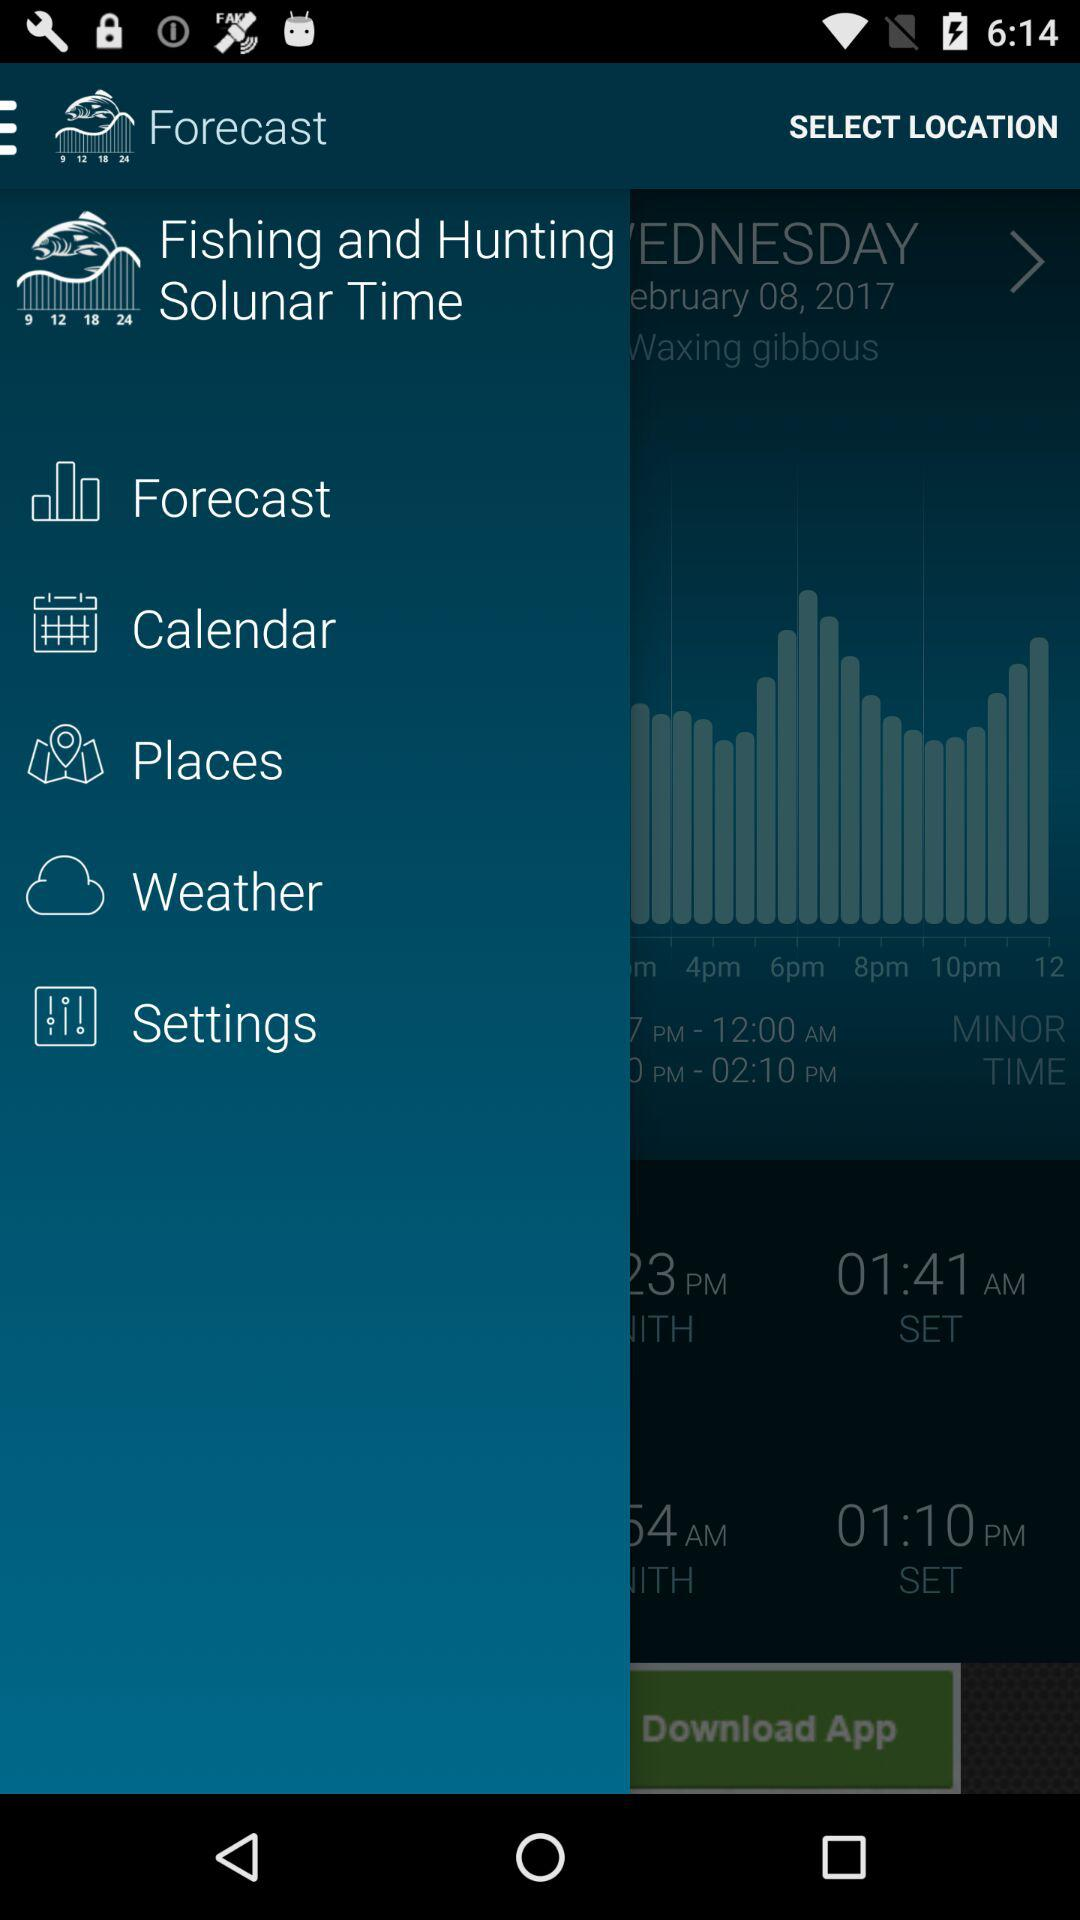What is the name of the moon phase that is currently in effect?
Answer the question using a single word or phrase. Waxing gibbous 